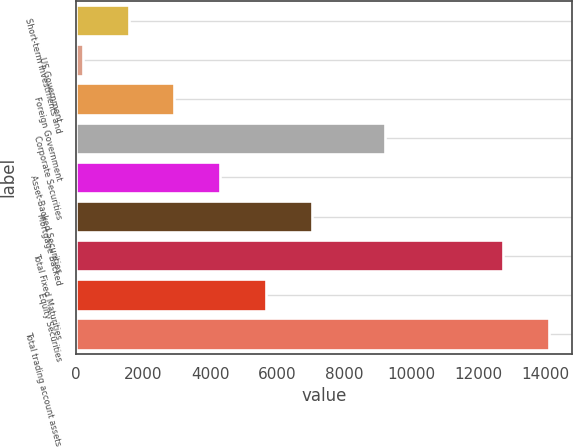Convert chart. <chart><loc_0><loc_0><loc_500><loc_500><bar_chart><fcel>Short-term Investments and<fcel>US Government<fcel>Foreign Government<fcel>Corporate Securities<fcel>Asset-Backed Securities<fcel>Mortgage Backed<fcel>Total Fixed Maturities<fcel>Equity Securities<fcel>Total trading account assets<nl><fcel>1570.9<fcel>206<fcel>2935.8<fcel>9207<fcel>4300.7<fcel>7030.5<fcel>12727<fcel>5665.6<fcel>14091.9<nl></chart> 